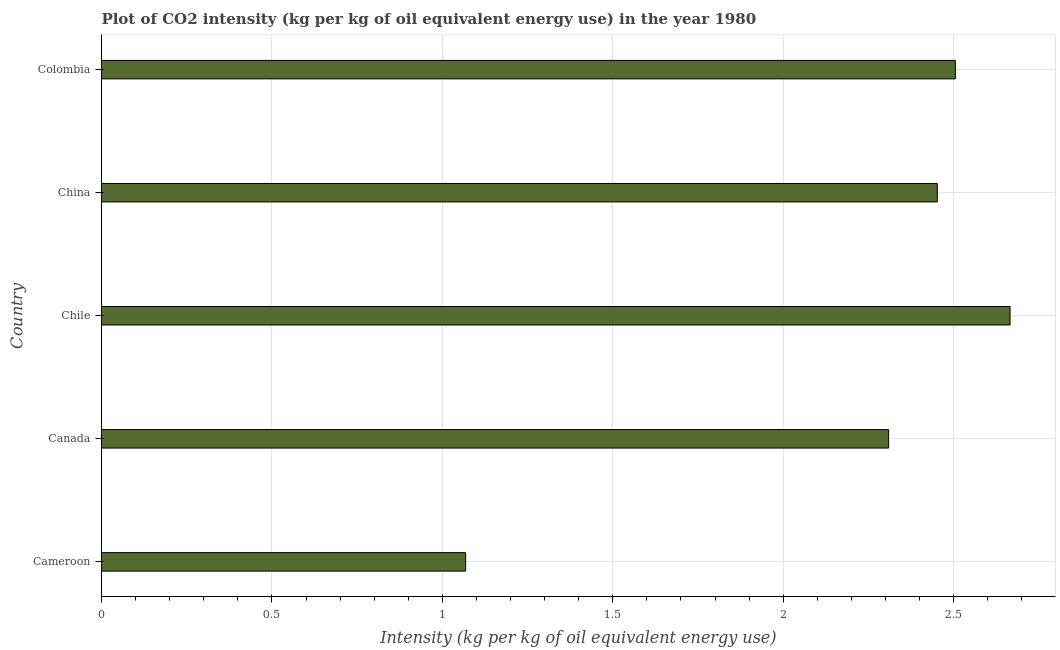Does the graph contain grids?
Offer a terse response. Yes. What is the title of the graph?
Keep it short and to the point. Plot of CO2 intensity (kg per kg of oil equivalent energy use) in the year 1980. What is the label or title of the X-axis?
Your answer should be compact. Intensity (kg per kg of oil equivalent energy use). What is the label or title of the Y-axis?
Ensure brevity in your answer.  Country. What is the co2 intensity in China?
Your response must be concise. 2.45. Across all countries, what is the maximum co2 intensity?
Provide a short and direct response. 2.67. Across all countries, what is the minimum co2 intensity?
Your answer should be compact. 1.07. In which country was the co2 intensity maximum?
Keep it short and to the point. Chile. In which country was the co2 intensity minimum?
Offer a terse response. Cameroon. What is the sum of the co2 intensity?
Provide a succinct answer. 11. What is the difference between the co2 intensity in Cameroon and Canada?
Your response must be concise. -1.24. What is the median co2 intensity?
Keep it short and to the point. 2.45. What is the ratio of the co2 intensity in Cameroon to that in Canada?
Your answer should be compact. 0.46. What is the difference between the highest and the second highest co2 intensity?
Give a very brief answer. 0.16. What is the difference between the highest and the lowest co2 intensity?
Make the answer very short. 1.6. In how many countries, is the co2 intensity greater than the average co2 intensity taken over all countries?
Your response must be concise. 4. How many bars are there?
Give a very brief answer. 5. Are all the bars in the graph horizontal?
Offer a terse response. Yes. How many countries are there in the graph?
Ensure brevity in your answer.  5. What is the difference between two consecutive major ticks on the X-axis?
Your answer should be compact. 0.5. Are the values on the major ticks of X-axis written in scientific E-notation?
Ensure brevity in your answer.  No. What is the Intensity (kg per kg of oil equivalent energy use) of Cameroon?
Make the answer very short. 1.07. What is the Intensity (kg per kg of oil equivalent energy use) in Canada?
Give a very brief answer. 2.31. What is the Intensity (kg per kg of oil equivalent energy use) in Chile?
Your answer should be compact. 2.67. What is the Intensity (kg per kg of oil equivalent energy use) of China?
Offer a terse response. 2.45. What is the Intensity (kg per kg of oil equivalent energy use) in Colombia?
Ensure brevity in your answer.  2.51. What is the difference between the Intensity (kg per kg of oil equivalent energy use) in Cameroon and Canada?
Ensure brevity in your answer.  -1.24. What is the difference between the Intensity (kg per kg of oil equivalent energy use) in Cameroon and Chile?
Your answer should be very brief. -1.6. What is the difference between the Intensity (kg per kg of oil equivalent energy use) in Cameroon and China?
Your response must be concise. -1.38. What is the difference between the Intensity (kg per kg of oil equivalent energy use) in Cameroon and Colombia?
Provide a short and direct response. -1.44. What is the difference between the Intensity (kg per kg of oil equivalent energy use) in Canada and Chile?
Keep it short and to the point. -0.36. What is the difference between the Intensity (kg per kg of oil equivalent energy use) in Canada and China?
Your answer should be very brief. -0.14. What is the difference between the Intensity (kg per kg of oil equivalent energy use) in Canada and Colombia?
Ensure brevity in your answer.  -0.2. What is the difference between the Intensity (kg per kg of oil equivalent energy use) in Chile and China?
Provide a succinct answer. 0.21. What is the difference between the Intensity (kg per kg of oil equivalent energy use) in Chile and Colombia?
Ensure brevity in your answer.  0.16. What is the difference between the Intensity (kg per kg of oil equivalent energy use) in China and Colombia?
Give a very brief answer. -0.05. What is the ratio of the Intensity (kg per kg of oil equivalent energy use) in Cameroon to that in Canada?
Offer a very short reply. 0.46. What is the ratio of the Intensity (kg per kg of oil equivalent energy use) in Cameroon to that in Chile?
Keep it short and to the point. 0.4. What is the ratio of the Intensity (kg per kg of oil equivalent energy use) in Cameroon to that in China?
Offer a very short reply. 0.44. What is the ratio of the Intensity (kg per kg of oil equivalent energy use) in Cameroon to that in Colombia?
Your response must be concise. 0.43. What is the ratio of the Intensity (kg per kg of oil equivalent energy use) in Canada to that in Chile?
Provide a succinct answer. 0.87. What is the ratio of the Intensity (kg per kg of oil equivalent energy use) in Canada to that in China?
Your answer should be very brief. 0.94. What is the ratio of the Intensity (kg per kg of oil equivalent energy use) in Canada to that in Colombia?
Offer a very short reply. 0.92. What is the ratio of the Intensity (kg per kg of oil equivalent energy use) in Chile to that in China?
Provide a short and direct response. 1.09. What is the ratio of the Intensity (kg per kg of oil equivalent energy use) in Chile to that in Colombia?
Your answer should be compact. 1.06. What is the ratio of the Intensity (kg per kg of oil equivalent energy use) in China to that in Colombia?
Your response must be concise. 0.98. 